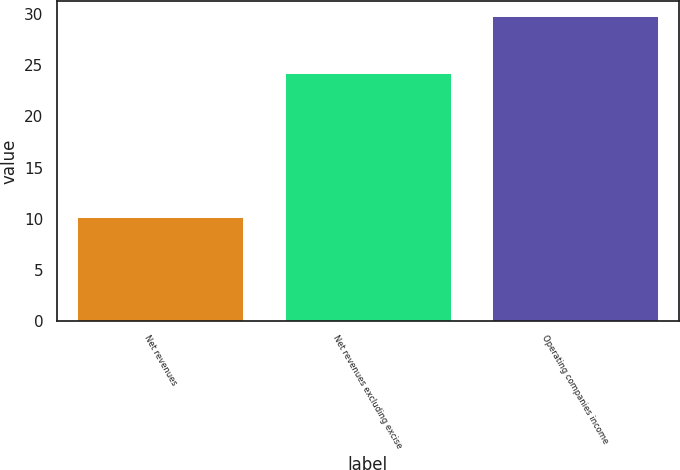Convert chart to OTSL. <chart><loc_0><loc_0><loc_500><loc_500><bar_chart><fcel>Net revenues<fcel>Net revenues excluding excise<fcel>Operating companies income<nl><fcel>10.2<fcel>24.3<fcel>29.8<nl></chart> 